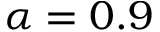<formula> <loc_0><loc_0><loc_500><loc_500>\alpha = 0 . 9</formula> 